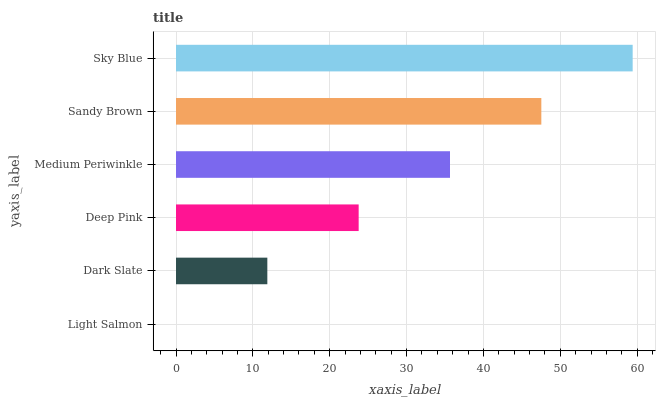Is Light Salmon the minimum?
Answer yes or no. Yes. Is Sky Blue the maximum?
Answer yes or no. Yes. Is Dark Slate the minimum?
Answer yes or no. No. Is Dark Slate the maximum?
Answer yes or no. No. Is Dark Slate greater than Light Salmon?
Answer yes or no. Yes. Is Light Salmon less than Dark Slate?
Answer yes or no. Yes. Is Light Salmon greater than Dark Slate?
Answer yes or no. No. Is Dark Slate less than Light Salmon?
Answer yes or no. No. Is Medium Periwinkle the high median?
Answer yes or no. Yes. Is Deep Pink the low median?
Answer yes or no. Yes. Is Dark Slate the high median?
Answer yes or no. No. Is Light Salmon the low median?
Answer yes or no. No. 